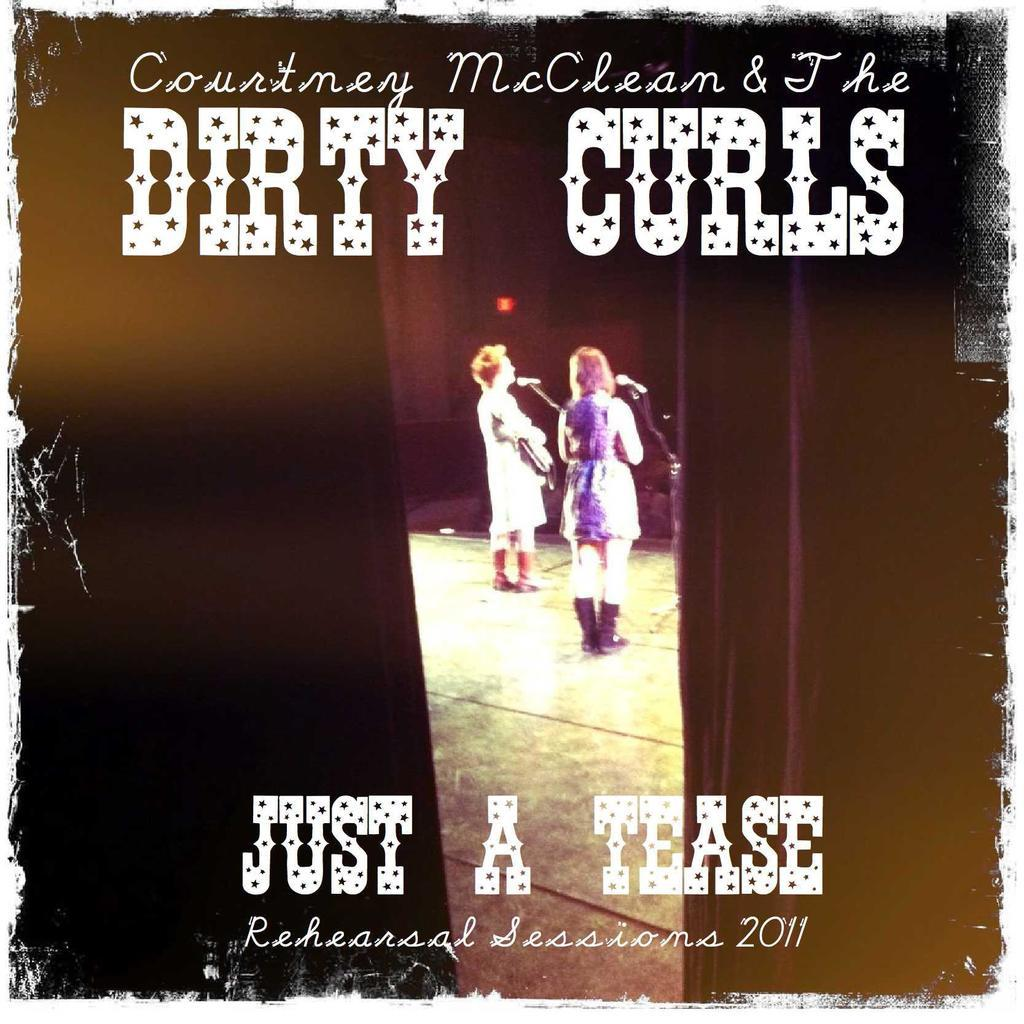<image>
Provide a brief description of the given image. A poster for the group Courtney McClean and The Dirty Curls shows people singing on stage. 